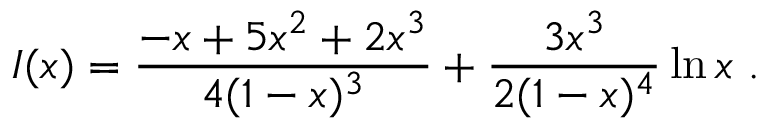Convert formula to latex. <formula><loc_0><loc_0><loc_500><loc_500>I ( x ) = \frac { - x + 5 x ^ { 2 } + 2 x ^ { 3 } } { 4 ( 1 - x ) ^ { 3 } } + \frac { 3 x ^ { 3 } } { 2 ( 1 - x ) ^ { 4 } } \ln x \ .</formula> 